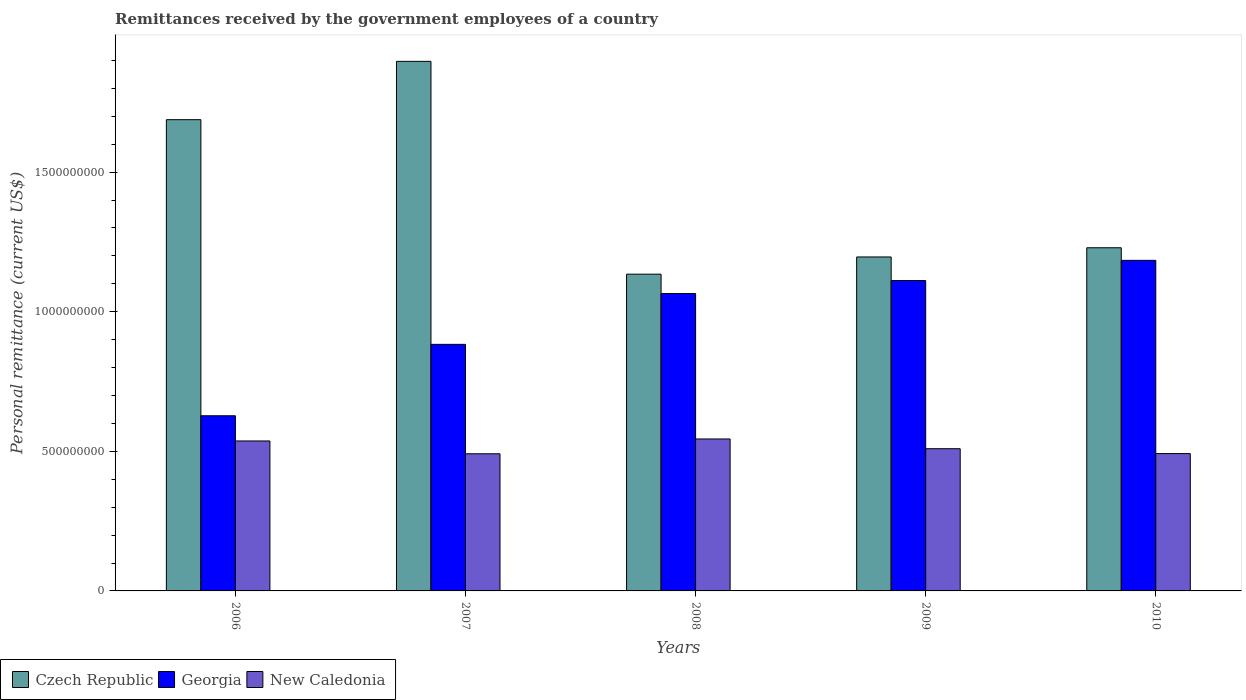Are the number of bars per tick equal to the number of legend labels?
Ensure brevity in your answer.  Yes. How many bars are there on the 1st tick from the right?
Offer a very short reply. 3. In how many cases, is the number of bars for a given year not equal to the number of legend labels?
Give a very brief answer. 0. What is the remittances received by the government employees in Georgia in 2010?
Offer a terse response. 1.18e+09. Across all years, what is the maximum remittances received by the government employees in New Caledonia?
Make the answer very short. 5.44e+08. Across all years, what is the minimum remittances received by the government employees in Georgia?
Offer a terse response. 6.27e+08. In which year was the remittances received by the government employees in Georgia maximum?
Offer a very short reply. 2010. In which year was the remittances received by the government employees in Georgia minimum?
Offer a terse response. 2006. What is the total remittances received by the government employees in Czech Republic in the graph?
Your answer should be very brief. 7.14e+09. What is the difference between the remittances received by the government employees in Czech Republic in 2007 and that in 2010?
Your answer should be compact. 6.68e+08. What is the difference between the remittances received by the government employees in Czech Republic in 2009 and the remittances received by the government employees in New Caledonia in 2006?
Your response must be concise. 6.59e+08. What is the average remittances received by the government employees in New Caledonia per year?
Make the answer very short. 5.15e+08. In the year 2006, what is the difference between the remittances received by the government employees in New Caledonia and remittances received by the government employees in Czech Republic?
Make the answer very short. -1.15e+09. In how many years, is the remittances received by the government employees in Georgia greater than 1700000000 US$?
Offer a very short reply. 0. What is the ratio of the remittances received by the government employees in New Caledonia in 2006 to that in 2009?
Your answer should be compact. 1.05. What is the difference between the highest and the second highest remittances received by the government employees in Czech Republic?
Make the answer very short. 2.09e+08. What is the difference between the highest and the lowest remittances received by the government employees in Czech Republic?
Provide a short and direct response. 7.62e+08. What does the 2nd bar from the left in 2010 represents?
Give a very brief answer. Georgia. What does the 1st bar from the right in 2007 represents?
Provide a short and direct response. New Caledonia. How many bars are there?
Your answer should be very brief. 15. Are all the bars in the graph horizontal?
Provide a short and direct response. No. What is the difference between two consecutive major ticks on the Y-axis?
Your answer should be very brief. 5.00e+08. Does the graph contain any zero values?
Ensure brevity in your answer.  No. Does the graph contain grids?
Ensure brevity in your answer.  No. Where does the legend appear in the graph?
Offer a terse response. Bottom left. How many legend labels are there?
Provide a succinct answer. 3. How are the legend labels stacked?
Keep it short and to the point. Horizontal. What is the title of the graph?
Provide a succinct answer. Remittances received by the government employees of a country. What is the label or title of the X-axis?
Ensure brevity in your answer.  Years. What is the label or title of the Y-axis?
Provide a short and direct response. Personal remittance (current US$). What is the Personal remittance (current US$) of Czech Republic in 2006?
Provide a short and direct response. 1.69e+09. What is the Personal remittance (current US$) of Georgia in 2006?
Ensure brevity in your answer.  6.27e+08. What is the Personal remittance (current US$) of New Caledonia in 2006?
Keep it short and to the point. 5.37e+08. What is the Personal remittance (current US$) in Czech Republic in 2007?
Your answer should be very brief. 1.90e+09. What is the Personal remittance (current US$) in Georgia in 2007?
Give a very brief answer. 8.83e+08. What is the Personal remittance (current US$) of New Caledonia in 2007?
Your answer should be very brief. 4.91e+08. What is the Personal remittance (current US$) of Czech Republic in 2008?
Keep it short and to the point. 1.13e+09. What is the Personal remittance (current US$) in Georgia in 2008?
Make the answer very short. 1.07e+09. What is the Personal remittance (current US$) in New Caledonia in 2008?
Offer a terse response. 5.44e+08. What is the Personal remittance (current US$) of Czech Republic in 2009?
Your answer should be very brief. 1.20e+09. What is the Personal remittance (current US$) in Georgia in 2009?
Your answer should be very brief. 1.11e+09. What is the Personal remittance (current US$) of New Caledonia in 2009?
Give a very brief answer. 5.09e+08. What is the Personal remittance (current US$) of Czech Republic in 2010?
Provide a succinct answer. 1.23e+09. What is the Personal remittance (current US$) of Georgia in 2010?
Offer a terse response. 1.18e+09. What is the Personal remittance (current US$) in New Caledonia in 2010?
Make the answer very short. 4.92e+08. Across all years, what is the maximum Personal remittance (current US$) in Czech Republic?
Your response must be concise. 1.90e+09. Across all years, what is the maximum Personal remittance (current US$) of Georgia?
Provide a short and direct response. 1.18e+09. Across all years, what is the maximum Personal remittance (current US$) in New Caledonia?
Provide a short and direct response. 5.44e+08. Across all years, what is the minimum Personal remittance (current US$) of Czech Republic?
Provide a short and direct response. 1.13e+09. Across all years, what is the minimum Personal remittance (current US$) of Georgia?
Your answer should be very brief. 6.27e+08. Across all years, what is the minimum Personal remittance (current US$) of New Caledonia?
Offer a terse response. 4.91e+08. What is the total Personal remittance (current US$) in Czech Republic in the graph?
Your answer should be compact. 7.14e+09. What is the total Personal remittance (current US$) in Georgia in the graph?
Provide a succinct answer. 4.87e+09. What is the total Personal remittance (current US$) of New Caledonia in the graph?
Provide a short and direct response. 2.57e+09. What is the difference between the Personal remittance (current US$) in Czech Republic in 2006 and that in 2007?
Your response must be concise. -2.09e+08. What is the difference between the Personal remittance (current US$) in Georgia in 2006 and that in 2007?
Offer a very short reply. -2.56e+08. What is the difference between the Personal remittance (current US$) in New Caledonia in 2006 and that in 2007?
Make the answer very short. 4.59e+07. What is the difference between the Personal remittance (current US$) of Czech Republic in 2006 and that in 2008?
Make the answer very short. 5.53e+08. What is the difference between the Personal remittance (current US$) in Georgia in 2006 and that in 2008?
Offer a terse response. -4.38e+08. What is the difference between the Personal remittance (current US$) in New Caledonia in 2006 and that in 2008?
Your response must be concise. -7.16e+06. What is the difference between the Personal remittance (current US$) in Czech Republic in 2006 and that in 2009?
Offer a terse response. 4.92e+08. What is the difference between the Personal remittance (current US$) of Georgia in 2006 and that in 2009?
Offer a very short reply. -4.84e+08. What is the difference between the Personal remittance (current US$) of New Caledonia in 2006 and that in 2009?
Ensure brevity in your answer.  2.77e+07. What is the difference between the Personal remittance (current US$) of Czech Republic in 2006 and that in 2010?
Offer a very short reply. 4.59e+08. What is the difference between the Personal remittance (current US$) in Georgia in 2006 and that in 2010?
Keep it short and to the point. -5.57e+08. What is the difference between the Personal remittance (current US$) of New Caledonia in 2006 and that in 2010?
Your answer should be compact. 4.52e+07. What is the difference between the Personal remittance (current US$) in Czech Republic in 2007 and that in 2008?
Provide a succinct answer. 7.62e+08. What is the difference between the Personal remittance (current US$) in Georgia in 2007 and that in 2008?
Your answer should be compact. -1.82e+08. What is the difference between the Personal remittance (current US$) of New Caledonia in 2007 and that in 2008?
Make the answer very short. -5.30e+07. What is the difference between the Personal remittance (current US$) in Czech Republic in 2007 and that in 2009?
Provide a succinct answer. 7.01e+08. What is the difference between the Personal remittance (current US$) of Georgia in 2007 and that in 2009?
Ensure brevity in your answer.  -2.29e+08. What is the difference between the Personal remittance (current US$) of New Caledonia in 2007 and that in 2009?
Provide a short and direct response. -1.82e+07. What is the difference between the Personal remittance (current US$) in Czech Republic in 2007 and that in 2010?
Provide a short and direct response. 6.68e+08. What is the difference between the Personal remittance (current US$) of Georgia in 2007 and that in 2010?
Give a very brief answer. -3.01e+08. What is the difference between the Personal remittance (current US$) of New Caledonia in 2007 and that in 2010?
Your answer should be very brief. -6.58e+05. What is the difference between the Personal remittance (current US$) in Czech Republic in 2008 and that in 2009?
Make the answer very short. -6.16e+07. What is the difference between the Personal remittance (current US$) in Georgia in 2008 and that in 2009?
Keep it short and to the point. -4.66e+07. What is the difference between the Personal remittance (current US$) in New Caledonia in 2008 and that in 2009?
Your answer should be very brief. 3.49e+07. What is the difference between the Personal remittance (current US$) of Czech Republic in 2008 and that in 2010?
Your response must be concise. -9.46e+07. What is the difference between the Personal remittance (current US$) of Georgia in 2008 and that in 2010?
Keep it short and to the point. -1.19e+08. What is the difference between the Personal remittance (current US$) of New Caledonia in 2008 and that in 2010?
Your response must be concise. 5.24e+07. What is the difference between the Personal remittance (current US$) in Czech Republic in 2009 and that in 2010?
Make the answer very short. -3.30e+07. What is the difference between the Personal remittance (current US$) of Georgia in 2009 and that in 2010?
Keep it short and to the point. -7.23e+07. What is the difference between the Personal remittance (current US$) in New Caledonia in 2009 and that in 2010?
Your response must be concise. 1.75e+07. What is the difference between the Personal remittance (current US$) of Czech Republic in 2006 and the Personal remittance (current US$) of Georgia in 2007?
Provide a short and direct response. 8.05e+08. What is the difference between the Personal remittance (current US$) of Czech Republic in 2006 and the Personal remittance (current US$) of New Caledonia in 2007?
Offer a very short reply. 1.20e+09. What is the difference between the Personal remittance (current US$) of Georgia in 2006 and the Personal remittance (current US$) of New Caledonia in 2007?
Offer a terse response. 1.36e+08. What is the difference between the Personal remittance (current US$) in Czech Republic in 2006 and the Personal remittance (current US$) in Georgia in 2008?
Your response must be concise. 6.23e+08. What is the difference between the Personal remittance (current US$) of Czech Republic in 2006 and the Personal remittance (current US$) of New Caledonia in 2008?
Your answer should be compact. 1.14e+09. What is the difference between the Personal remittance (current US$) in Georgia in 2006 and the Personal remittance (current US$) in New Caledonia in 2008?
Your answer should be compact. 8.31e+07. What is the difference between the Personal remittance (current US$) in Czech Republic in 2006 and the Personal remittance (current US$) in Georgia in 2009?
Your response must be concise. 5.76e+08. What is the difference between the Personal remittance (current US$) in Czech Republic in 2006 and the Personal remittance (current US$) in New Caledonia in 2009?
Give a very brief answer. 1.18e+09. What is the difference between the Personal remittance (current US$) of Georgia in 2006 and the Personal remittance (current US$) of New Caledonia in 2009?
Ensure brevity in your answer.  1.18e+08. What is the difference between the Personal remittance (current US$) of Czech Republic in 2006 and the Personal remittance (current US$) of Georgia in 2010?
Your response must be concise. 5.04e+08. What is the difference between the Personal remittance (current US$) of Czech Republic in 2006 and the Personal remittance (current US$) of New Caledonia in 2010?
Your answer should be very brief. 1.20e+09. What is the difference between the Personal remittance (current US$) in Georgia in 2006 and the Personal remittance (current US$) in New Caledonia in 2010?
Ensure brevity in your answer.  1.36e+08. What is the difference between the Personal remittance (current US$) of Czech Republic in 2007 and the Personal remittance (current US$) of Georgia in 2008?
Make the answer very short. 8.32e+08. What is the difference between the Personal remittance (current US$) of Czech Republic in 2007 and the Personal remittance (current US$) of New Caledonia in 2008?
Your answer should be compact. 1.35e+09. What is the difference between the Personal remittance (current US$) in Georgia in 2007 and the Personal remittance (current US$) in New Caledonia in 2008?
Your answer should be very brief. 3.39e+08. What is the difference between the Personal remittance (current US$) of Czech Republic in 2007 and the Personal remittance (current US$) of Georgia in 2009?
Offer a terse response. 7.85e+08. What is the difference between the Personal remittance (current US$) in Czech Republic in 2007 and the Personal remittance (current US$) in New Caledonia in 2009?
Your answer should be compact. 1.39e+09. What is the difference between the Personal remittance (current US$) of Georgia in 2007 and the Personal remittance (current US$) of New Caledonia in 2009?
Make the answer very short. 3.74e+08. What is the difference between the Personal remittance (current US$) in Czech Republic in 2007 and the Personal remittance (current US$) in Georgia in 2010?
Keep it short and to the point. 7.13e+08. What is the difference between the Personal remittance (current US$) of Czech Republic in 2007 and the Personal remittance (current US$) of New Caledonia in 2010?
Provide a short and direct response. 1.40e+09. What is the difference between the Personal remittance (current US$) of Georgia in 2007 and the Personal remittance (current US$) of New Caledonia in 2010?
Your answer should be very brief. 3.91e+08. What is the difference between the Personal remittance (current US$) of Czech Republic in 2008 and the Personal remittance (current US$) of Georgia in 2009?
Provide a short and direct response. 2.28e+07. What is the difference between the Personal remittance (current US$) in Czech Republic in 2008 and the Personal remittance (current US$) in New Caledonia in 2009?
Ensure brevity in your answer.  6.25e+08. What is the difference between the Personal remittance (current US$) in Georgia in 2008 and the Personal remittance (current US$) in New Caledonia in 2009?
Make the answer very short. 5.56e+08. What is the difference between the Personal remittance (current US$) of Czech Republic in 2008 and the Personal remittance (current US$) of Georgia in 2010?
Ensure brevity in your answer.  -4.95e+07. What is the difference between the Personal remittance (current US$) in Czech Republic in 2008 and the Personal remittance (current US$) in New Caledonia in 2010?
Your response must be concise. 6.43e+08. What is the difference between the Personal remittance (current US$) of Georgia in 2008 and the Personal remittance (current US$) of New Caledonia in 2010?
Your answer should be very brief. 5.73e+08. What is the difference between the Personal remittance (current US$) of Czech Republic in 2009 and the Personal remittance (current US$) of Georgia in 2010?
Ensure brevity in your answer.  1.21e+07. What is the difference between the Personal remittance (current US$) in Czech Republic in 2009 and the Personal remittance (current US$) in New Caledonia in 2010?
Your answer should be compact. 7.04e+08. What is the difference between the Personal remittance (current US$) of Georgia in 2009 and the Personal remittance (current US$) of New Caledonia in 2010?
Provide a short and direct response. 6.20e+08. What is the average Personal remittance (current US$) in Czech Republic per year?
Offer a terse response. 1.43e+09. What is the average Personal remittance (current US$) of Georgia per year?
Ensure brevity in your answer.  9.74e+08. What is the average Personal remittance (current US$) in New Caledonia per year?
Provide a short and direct response. 5.15e+08. In the year 2006, what is the difference between the Personal remittance (current US$) of Czech Republic and Personal remittance (current US$) of Georgia?
Provide a short and direct response. 1.06e+09. In the year 2006, what is the difference between the Personal remittance (current US$) in Czech Republic and Personal remittance (current US$) in New Caledonia?
Give a very brief answer. 1.15e+09. In the year 2006, what is the difference between the Personal remittance (current US$) in Georgia and Personal remittance (current US$) in New Caledonia?
Your answer should be compact. 9.03e+07. In the year 2007, what is the difference between the Personal remittance (current US$) of Czech Republic and Personal remittance (current US$) of Georgia?
Offer a terse response. 1.01e+09. In the year 2007, what is the difference between the Personal remittance (current US$) of Czech Republic and Personal remittance (current US$) of New Caledonia?
Your answer should be very brief. 1.41e+09. In the year 2007, what is the difference between the Personal remittance (current US$) in Georgia and Personal remittance (current US$) in New Caledonia?
Your response must be concise. 3.92e+08. In the year 2008, what is the difference between the Personal remittance (current US$) of Czech Republic and Personal remittance (current US$) of Georgia?
Provide a succinct answer. 6.94e+07. In the year 2008, what is the difference between the Personal remittance (current US$) of Czech Republic and Personal remittance (current US$) of New Caledonia?
Make the answer very short. 5.90e+08. In the year 2008, what is the difference between the Personal remittance (current US$) of Georgia and Personal remittance (current US$) of New Caledonia?
Offer a very short reply. 5.21e+08. In the year 2009, what is the difference between the Personal remittance (current US$) in Czech Republic and Personal remittance (current US$) in Georgia?
Your answer should be compact. 8.45e+07. In the year 2009, what is the difference between the Personal remittance (current US$) of Czech Republic and Personal remittance (current US$) of New Caledonia?
Make the answer very short. 6.87e+08. In the year 2009, what is the difference between the Personal remittance (current US$) in Georgia and Personal remittance (current US$) in New Caledonia?
Provide a short and direct response. 6.02e+08. In the year 2010, what is the difference between the Personal remittance (current US$) of Czech Republic and Personal remittance (current US$) of Georgia?
Offer a very short reply. 4.51e+07. In the year 2010, what is the difference between the Personal remittance (current US$) in Czech Republic and Personal remittance (current US$) in New Caledonia?
Your response must be concise. 7.37e+08. In the year 2010, what is the difference between the Personal remittance (current US$) in Georgia and Personal remittance (current US$) in New Caledonia?
Your answer should be very brief. 6.92e+08. What is the ratio of the Personal remittance (current US$) in Czech Republic in 2006 to that in 2007?
Your response must be concise. 0.89. What is the ratio of the Personal remittance (current US$) of Georgia in 2006 to that in 2007?
Your answer should be compact. 0.71. What is the ratio of the Personal remittance (current US$) in New Caledonia in 2006 to that in 2007?
Keep it short and to the point. 1.09. What is the ratio of the Personal remittance (current US$) in Czech Republic in 2006 to that in 2008?
Your response must be concise. 1.49. What is the ratio of the Personal remittance (current US$) of Georgia in 2006 to that in 2008?
Offer a very short reply. 0.59. What is the ratio of the Personal remittance (current US$) of New Caledonia in 2006 to that in 2008?
Your answer should be compact. 0.99. What is the ratio of the Personal remittance (current US$) of Czech Republic in 2006 to that in 2009?
Provide a succinct answer. 1.41. What is the ratio of the Personal remittance (current US$) of Georgia in 2006 to that in 2009?
Your response must be concise. 0.56. What is the ratio of the Personal remittance (current US$) in New Caledonia in 2006 to that in 2009?
Give a very brief answer. 1.05. What is the ratio of the Personal remittance (current US$) in Czech Republic in 2006 to that in 2010?
Your response must be concise. 1.37. What is the ratio of the Personal remittance (current US$) in Georgia in 2006 to that in 2010?
Provide a short and direct response. 0.53. What is the ratio of the Personal remittance (current US$) of New Caledonia in 2006 to that in 2010?
Ensure brevity in your answer.  1.09. What is the ratio of the Personal remittance (current US$) of Czech Republic in 2007 to that in 2008?
Your answer should be very brief. 1.67. What is the ratio of the Personal remittance (current US$) in Georgia in 2007 to that in 2008?
Your answer should be very brief. 0.83. What is the ratio of the Personal remittance (current US$) of New Caledonia in 2007 to that in 2008?
Your response must be concise. 0.9. What is the ratio of the Personal remittance (current US$) of Czech Republic in 2007 to that in 2009?
Ensure brevity in your answer.  1.59. What is the ratio of the Personal remittance (current US$) of Georgia in 2007 to that in 2009?
Offer a terse response. 0.79. What is the ratio of the Personal remittance (current US$) of Czech Republic in 2007 to that in 2010?
Your answer should be compact. 1.54. What is the ratio of the Personal remittance (current US$) in Georgia in 2007 to that in 2010?
Your response must be concise. 0.75. What is the ratio of the Personal remittance (current US$) in Czech Republic in 2008 to that in 2009?
Keep it short and to the point. 0.95. What is the ratio of the Personal remittance (current US$) in Georgia in 2008 to that in 2009?
Ensure brevity in your answer.  0.96. What is the ratio of the Personal remittance (current US$) of New Caledonia in 2008 to that in 2009?
Your answer should be compact. 1.07. What is the ratio of the Personal remittance (current US$) in Czech Republic in 2008 to that in 2010?
Provide a short and direct response. 0.92. What is the ratio of the Personal remittance (current US$) in Georgia in 2008 to that in 2010?
Make the answer very short. 0.9. What is the ratio of the Personal remittance (current US$) of New Caledonia in 2008 to that in 2010?
Give a very brief answer. 1.11. What is the ratio of the Personal remittance (current US$) in Czech Republic in 2009 to that in 2010?
Offer a terse response. 0.97. What is the ratio of the Personal remittance (current US$) in Georgia in 2009 to that in 2010?
Make the answer very short. 0.94. What is the ratio of the Personal remittance (current US$) in New Caledonia in 2009 to that in 2010?
Provide a short and direct response. 1.04. What is the difference between the highest and the second highest Personal remittance (current US$) of Czech Republic?
Offer a very short reply. 2.09e+08. What is the difference between the highest and the second highest Personal remittance (current US$) in Georgia?
Offer a very short reply. 7.23e+07. What is the difference between the highest and the second highest Personal remittance (current US$) of New Caledonia?
Provide a succinct answer. 7.16e+06. What is the difference between the highest and the lowest Personal remittance (current US$) of Czech Republic?
Your answer should be compact. 7.62e+08. What is the difference between the highest and the lowest Personal remittance (current US$) in Georgia?
Make the answer very short. 5.57e+08. What is the difference between the highest and the lowest Personal remittance (current US$) in New Caledonia?
Keep it short and to the point. 5.30e+07. 